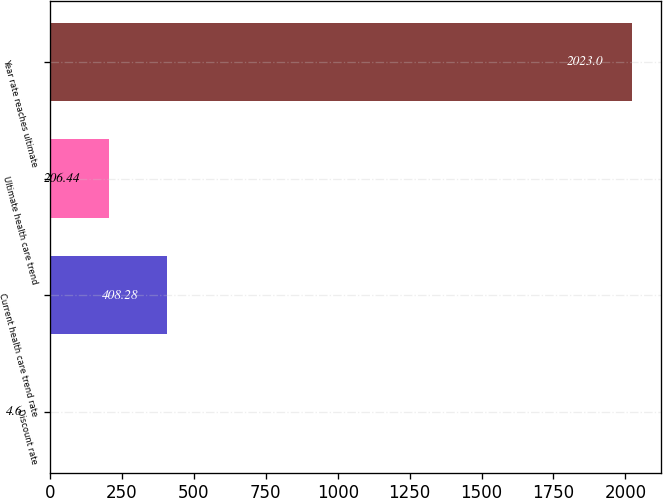<chart> <loc_0><loc_0><loc_500><loc_500><bar_chart><fcel>Discount rate<fcel>Current health care trend rate<fcel>Ultimate health care trend<fcel>Year rate reaches ultimate<nl><fcel>4.6<fcel>408.28<fcel>206.44<fcel>2023<nl></chart> 